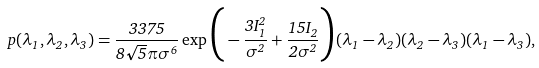<formula> <loc_0><loc_0><loc_500><loc_500>p ( \lambda _ { 1 } , \lambda _ { 2 } , \lambda _ { 3 } ) = \frac { 3 3 7 5 } { 8 \sqrt { 5 } \pi \sigma ^ { 6 } } \exp \Big { ( } - \frac { 3 I _ { 1 } ^ { 2 } } { \sigma ^ { 2 } } + \frac { 1 5 I _ { 2 } } { 2 \sigma ^ { 2 } } \Big { ) } ( \lambda _ { 1 } - \lambda _ { 2 } ) ( \lambda _ { 2 } - \lambda _ { 3 } ) ( \lambda _ { 1 } - \lambda _ { 3 } ) ,</formula> 